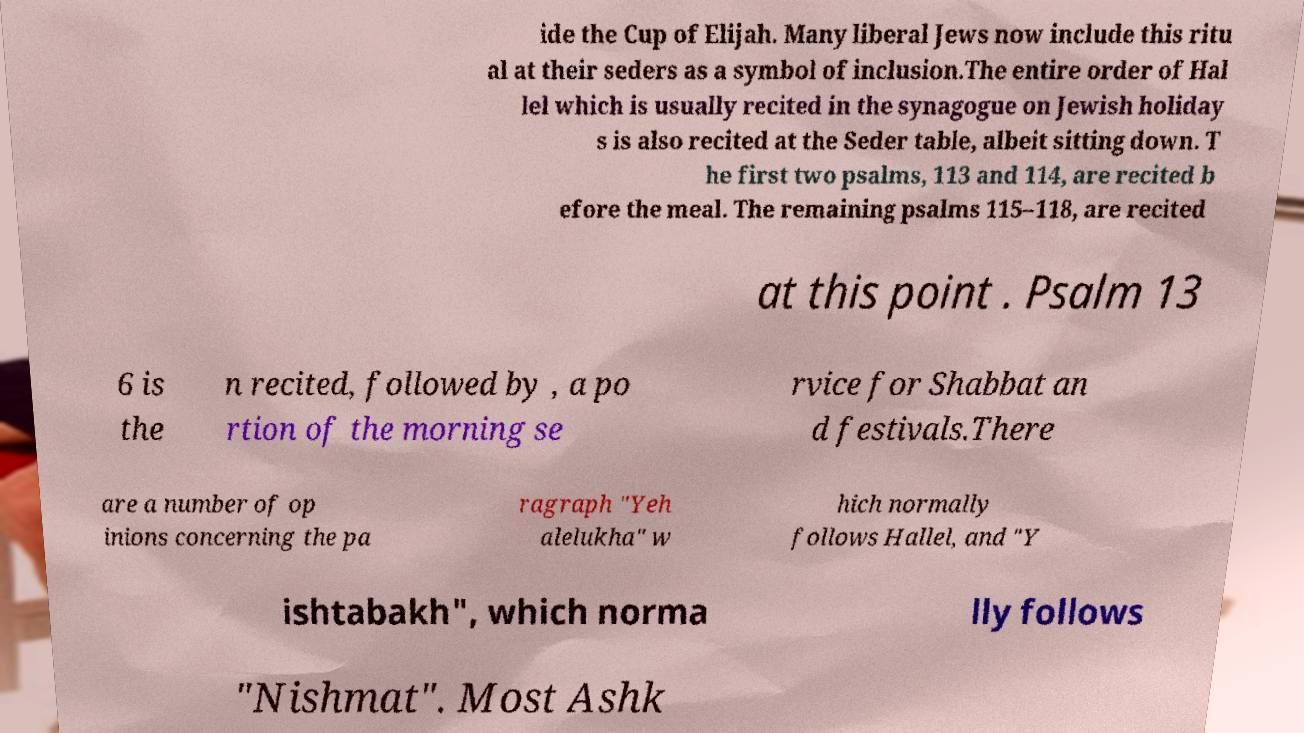I need the written content from this picture converted into text. Can you do that? ide the Cup of Elijah. Many liberal Jews now include this ritu al at their seders as a symbol of inclusion.The entire order of Hal lel which is usually recited in the synagogue on Jewish holiday s is also recited at the Seder table, albeit sitting down. T he first two psalms, 113 and 114, are recited b efore the meal. The remaining psalms 115–118, are recited at this point . Psalm 13 6 is the n recited, followed by , a po rtion of the morning se rvice for Shabbat an d festivals.There are a number of op inions concerning the pa ragraph "Yeh alelukha" w hich normally follows Hallel, and "Y ishtabakh", which norma lly follows "Nishmat". Most Ashk 